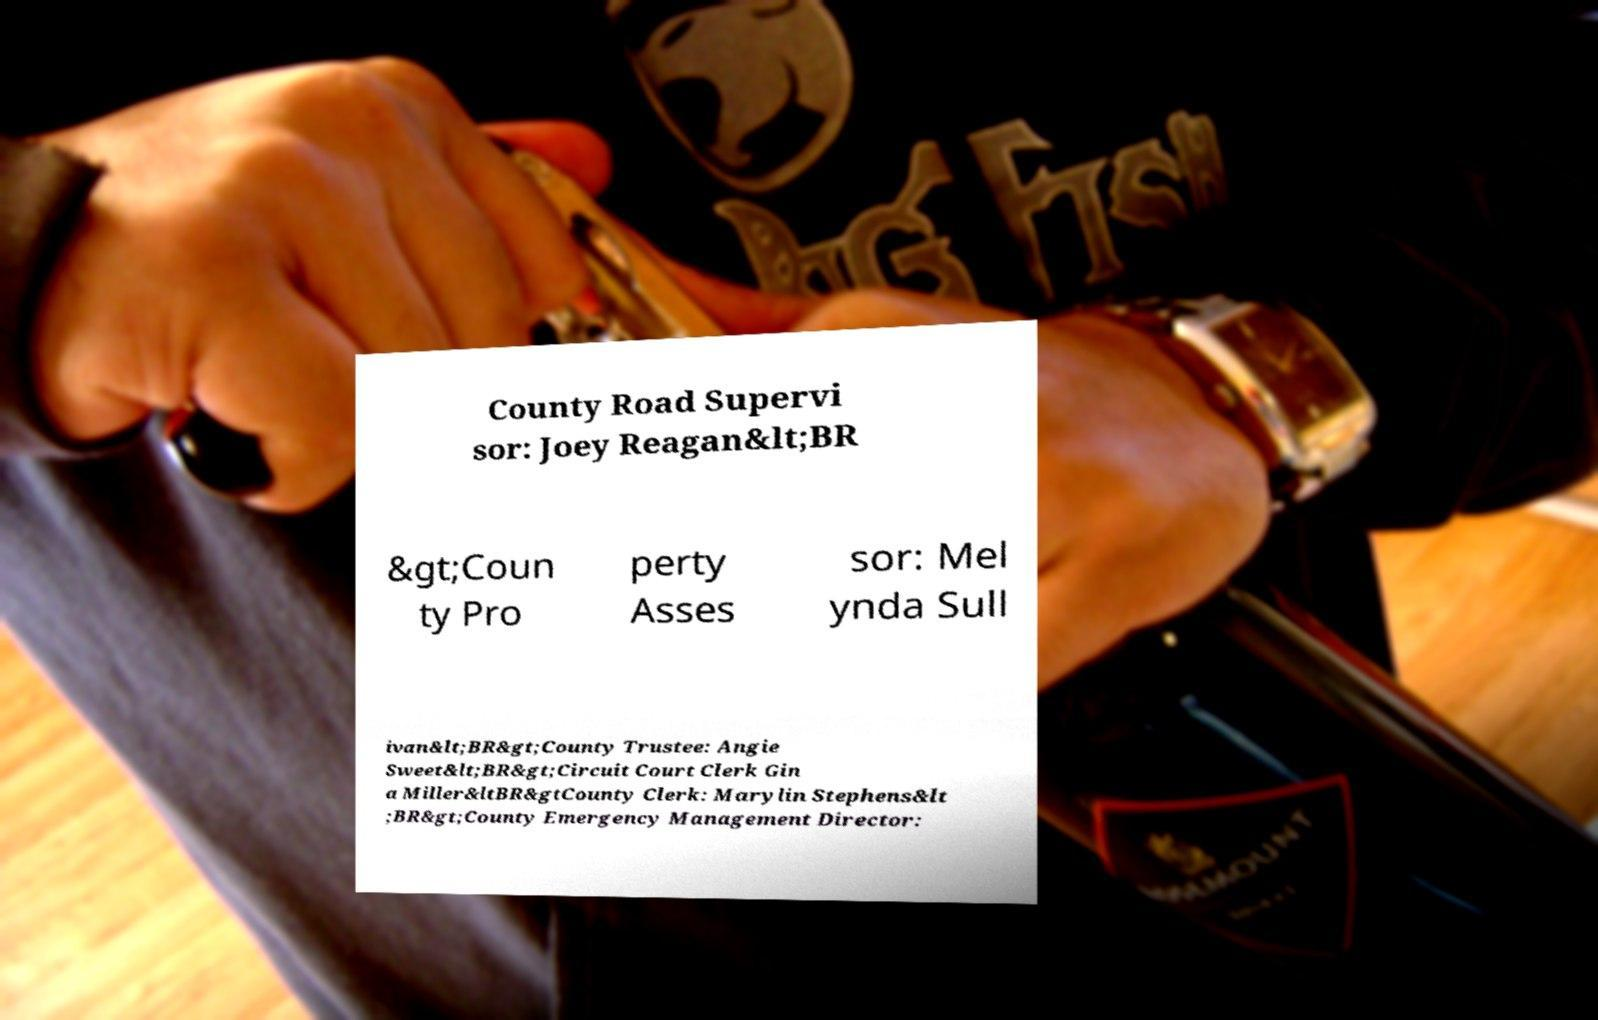For documentation purposes, I need the text within this image transcribed. Could you provide that? County Road Supervi sor: Joey Reagan&lt;BR &gt;Coun ty Pro perty Asses sor: Mel ynda Sull ivan&lt;BR&gt;County Trustee: Angie Sweet&lt;BR&gt;Circuit Court Clerk Gin a Miller&ltBR&gtCounty Clerk: Marylin Stephens&lt ;BR&gt;County Emergency Management Director: 